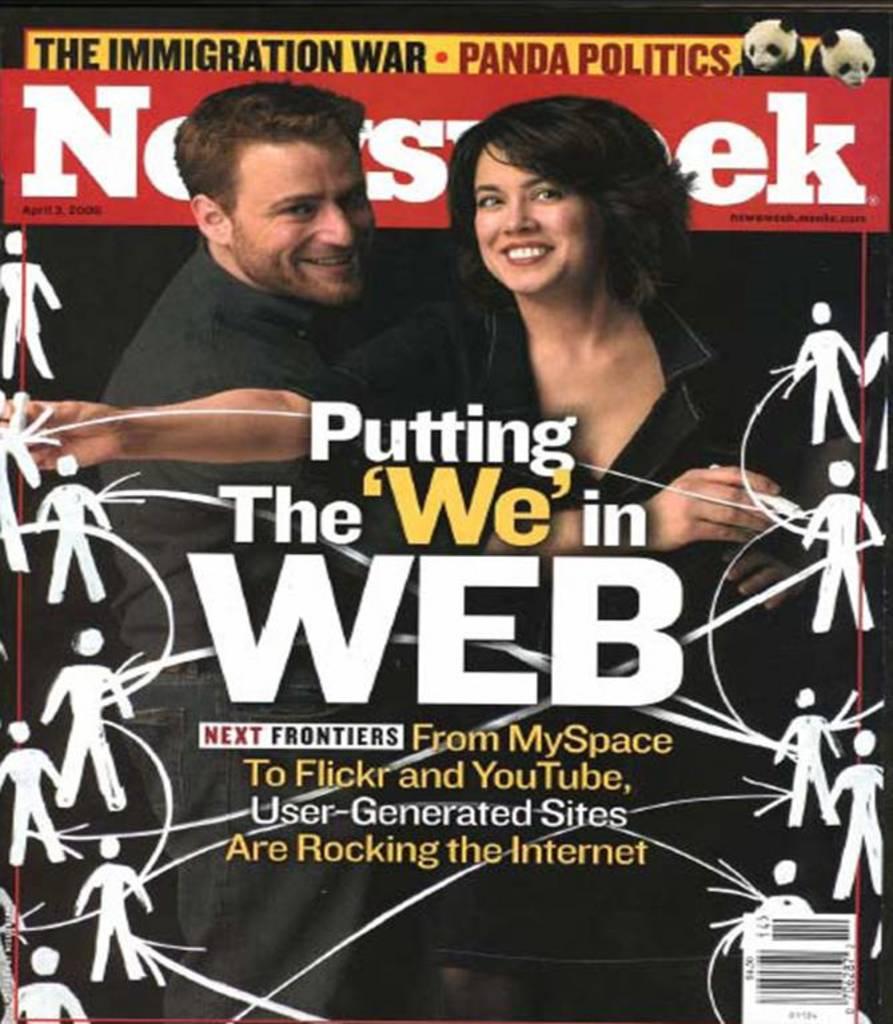What is the name of the magazine pictured?
Your answer should be very brief. Newsweek. Which war is featured in this magazine?
Make the answer very short. Immigration. 